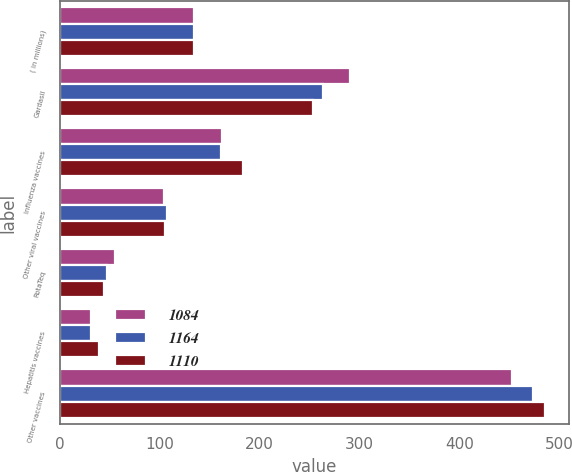Convert chart to OTSL. <chart><loc_0><loc_0><loc_500><loc_500><stacked_bar_chart><ecel><fcel>( in millions)<fcel>Gardasil<fcel>Influenza vaccines<fcel>Other viral vaccines<fcel>RotaTeq<fcel>Hepatitis vaccines<fcel>Other vaccines<nl><fcel>1084<fcel>134<fcel>291<fcel>162<fcel>104<fcel>55<fcel>31<fcel>453<nl><fcel>1164<fcel>134<fcel>264<fcel>161<fcel>107<fcel>47<fcel>31<fcel>474<nl><fcel>1110<fcel>134<fcel>253<fcel>183<fcel>105<fcel>44<fcel>39<fcel>486<nl></chart> 